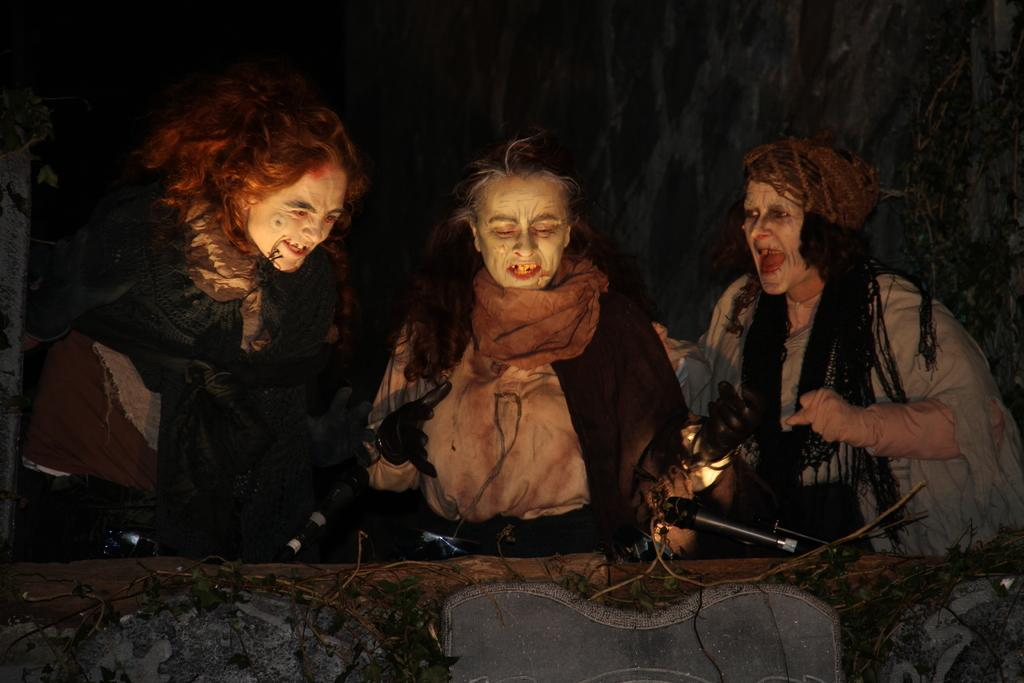How many people are in the image? There are three persons in the image. What are the persons wearing? The persons are wearing Halloween costumes. What objects can be seen in the image besides the people? There are microphones visible in the image. What type of vegetation is present at the bottom of the image? Leaves are present at the bottom of the image. How would you describe the lighting in the image? The background of the image is dark. What type of carpenter tools can be seen in the image? There are no carpenter tools present in the image. How are the persons transporting themselves in the image? The persons are not shown transporting themselves in the image; they are standing still. 